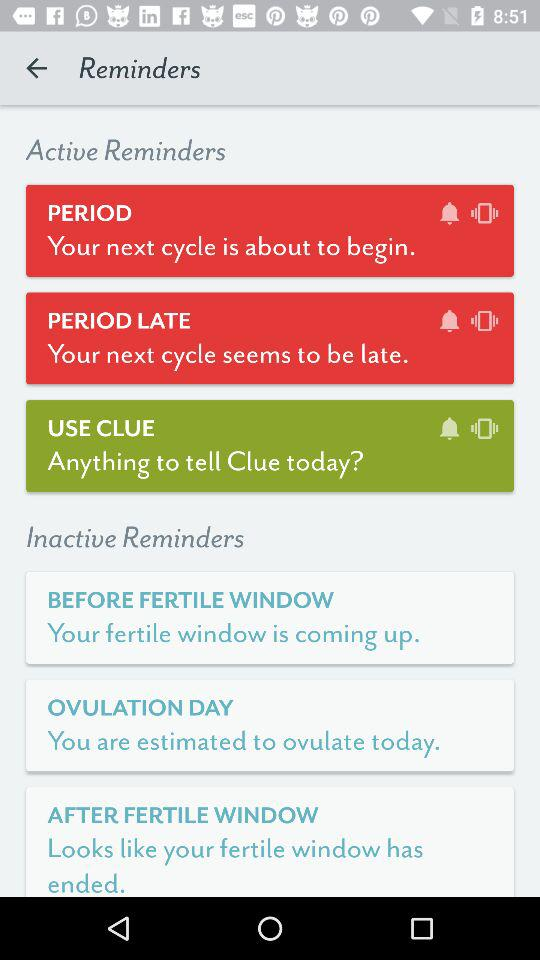How many reminders are inactive?
Answer the question using a single word or phrase. 3 